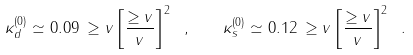Convert formula to latex. <formula><loc_0><loc_0><loc_500><loc_500>\kappa _ { d } ^ { ( 0 ) } \simeq 0 . 0 9 \, \geq v \left [ \frac { \geq v } { v } \right ] ^ { 2 } \ , \quad \kappa _ { s } ^ { ( 0 ) } \simeq 0 . 1 2 \, \geq v \left [ \frac { \geq v } { v } \right ] ^ { 2 } \ .</formula> 